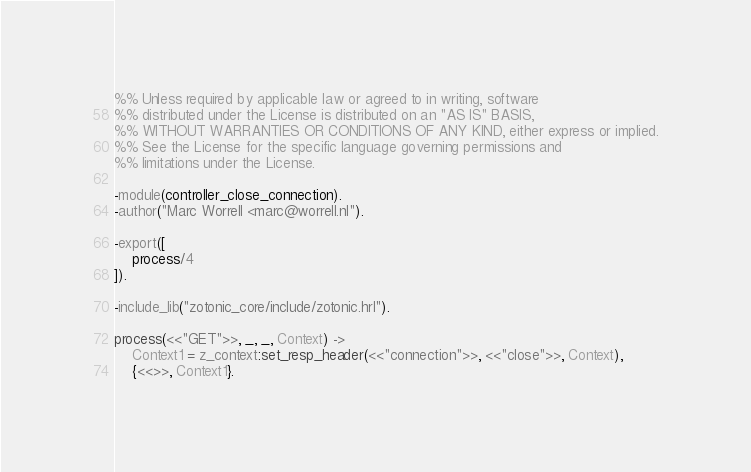Convert code to text. <code><loc_0><loc_0><loc_500><loc_500><_Erlang_>%% Unless required by applicable law or agreed to in writing, software
%% distributed under the License is distributed on an "AS IS" BASIS,
%% WITHOUT WARRANTIES OR CONDITIONS OF ANY KIND, either express or implied.
%% See the License for the specific language governing permissions and
%% limitations under the License.

-module(controller_close_connection).
-author("Marc Worrell <marc@worrell.nl").

-export([
    process/4
]).

-include_lib("zotonic_core/include/zotonic.hrl").

process(<<"GET">>, _, _, Context) ->
    Context1 = z_context:set_resp_header(<<"connection">>, <<"close">>, Context),
    {<<>>, Context1}.
</code> 